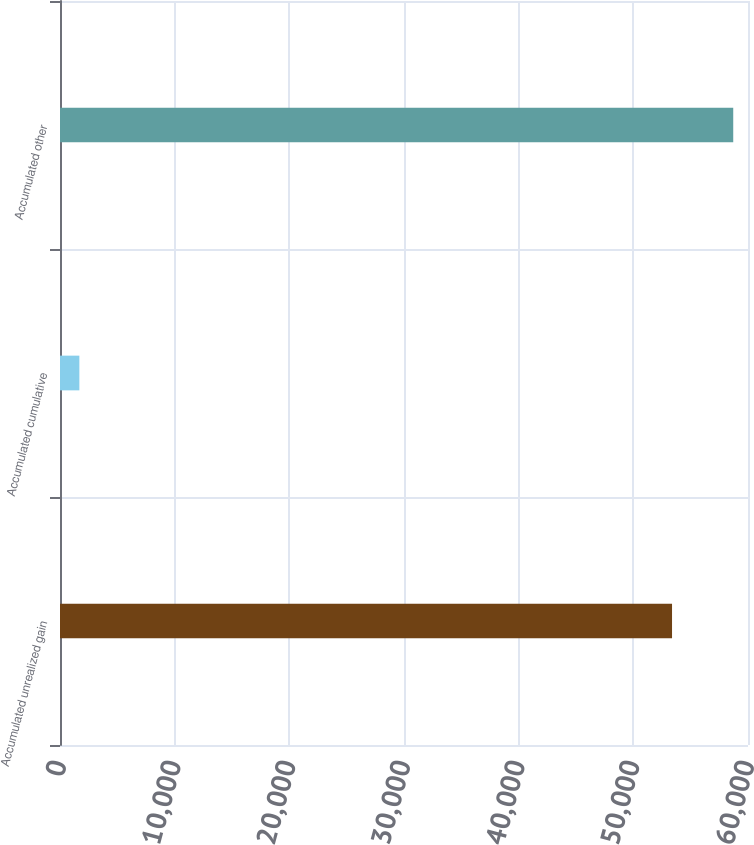<chart> <loc_0><loc_0><loc_500><loc_500><bar_chart><fcel>Accumulated unrealized gain<fcel>Accumulated cumulative<fcel>Accumulated other<nl><fcel>53375<fcel>1689<fcel>58712.5<nl></chart> 